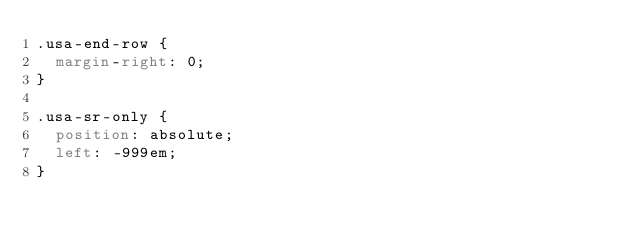<code> <loc_0><loc_0><loc_500><loc_500><_CSS_>.usa-end-row {
  margin-right: 0;
}

.usa-sr-only {
  position: absolute;
  left: -999em;
}</code> 